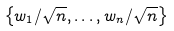<formula> <loc_0><loc_0><loc_500><loc_500>\left \{ { w } _ { 1 } / \sqrt { n } , \dots , { w } _ { n } / \sqrt { n } \right \}</formula> 